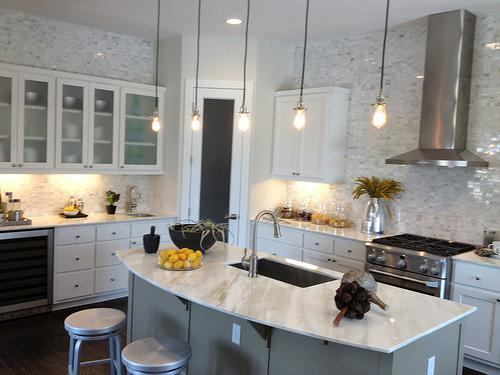Question: what color is the floor?
Choices:
A. Black.
B. White.
C. Brown.
D. Red.
Answer with the letter. Answer: C Question: what color is the kitchen?
Choices:
A. Yellow.
B. Green.
C. Pink.
D. White.
Answer with the letter. Answer: D Question: who is present?
Choices:
A. Barrak Obama.
B. Nobody.
C. Steven Tyler.
D. Harland Williams.
Answer with the letter. Answer: B Question: what else is visible?
Choices:
A. Kids.
B. Soldiers.
C. Mountains.
D. Chairs.
Answer with the letter. Answer: D 